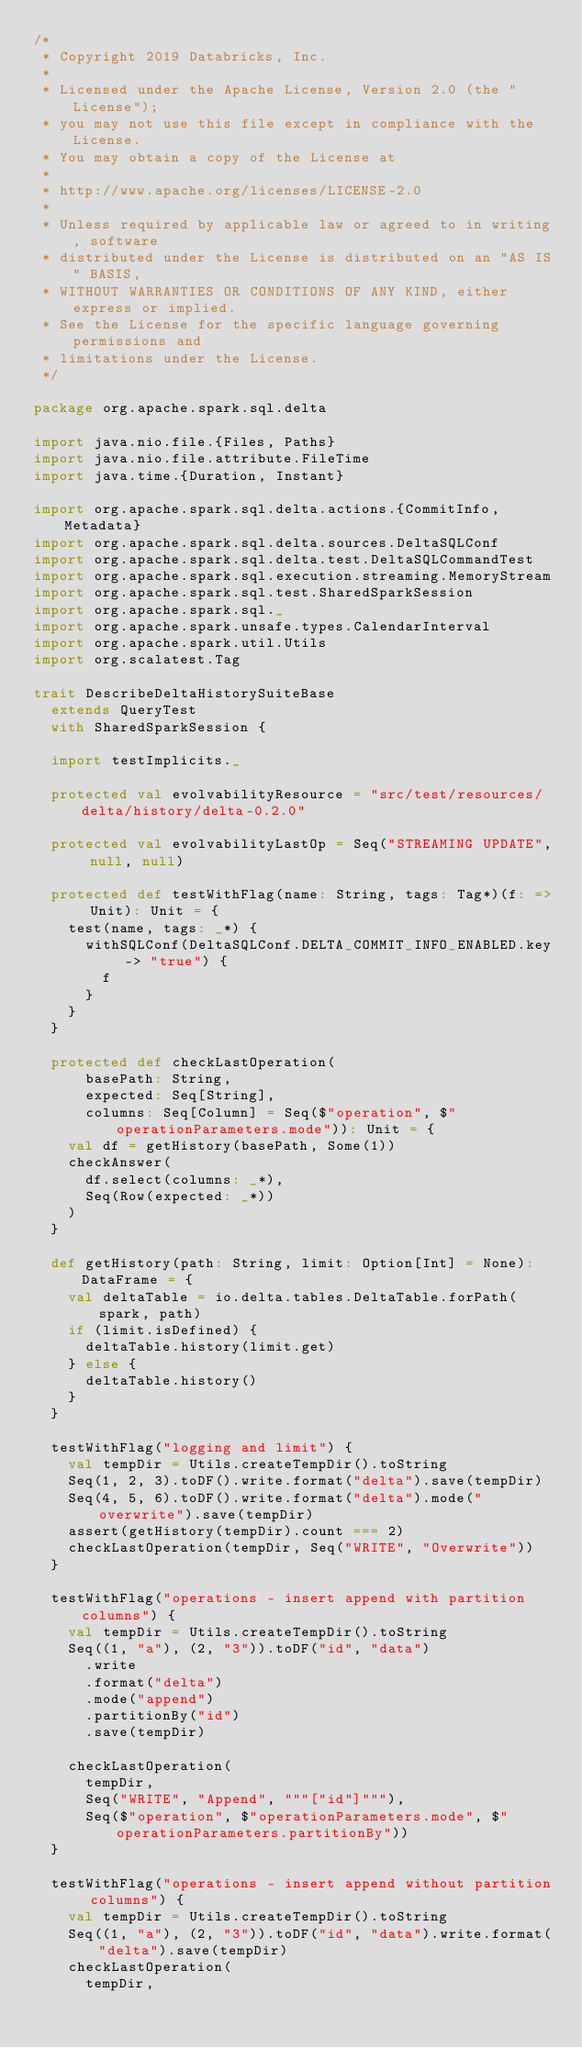<code> <loc_0><loc_0><loc_500><loc_500><_Scala_>/*
 * Copyright 2019 Databricks, Inc.
 *
 * Licensed under the Apache License, Version 2.0 (the "License");
 * you may not use this file except in compliance with the License.
 * You may obtain a copy of the License at
 *
 * http://www.apache.org/licenses/LICENSE-2.0
 *
 * Unless required by applicable law or agreed to in writing, software
 * distributed under the License is distributed on an "AS IS" BASIS,
 * WITHOUT WARRANTIES OR CONDITIONS OF ANY KIND, either express or implied.
 * See the License for the specific language governing permissions and
 * limitations under the License.
 */

package org.apache.spark.sql.delta

import java.nio.file.{Files, Paths}
import java.nio.file.attribute.FileTime
import java.time.{Duration, Instant}

import org.apache.spark.sql.delta.actions.{CommitInfo, Metadata}
import org.apache.spark.sql.delta.sources.DeltaSQLConf
import org.apache.spark.sql.delta.test.DeltaSQLCommandTest
import org.apache.spark.sql.execution.streaming.MemoryStream
import org.apache.spark.sql.test.SharedSparkSession
import org.apache.spark.sql._
import org.apache.spark.unsafe.types.CalendarInterval
import org.apache.spark.util.Utils
import org.scalatest.Tag

trait DescribeDeltaHistorySuiteBase
  extends QueryTest
  with SharedSparkSession {

  import testImplicits._

  protected val evolvabilityResource = "src/test/resources/delta/history/delta-0.2.0"

  protected val evolvabilityLastOp = Seq("STREAMING UPDATE", null, null)

  protected def testWithFlag(name: String, tags: Tag*)(f: => Unit): Unit = {
    test(name, tags: _*) {
      withSQLConf(DeltaSQLConf.DELTA_COMMIT_INFO_ENABLED.key -> "true") {
        f
      }
    }
  }

  protected def checkLastOperation(
      basePath: String,
      expected: Seq[String],
      columns: Seq[Column] = Seq($"operation", $"operationParameters.mode")): Unit = {
    val df = getHistory(basePath, Some(1))
    checkAnswer(
      df.select(columns: _*),
      Seq(Row(expected: _*))
    )
  }

  def getHistory(path: String, limit: Option[Int] = None): DataFrame = {
    val deltaTable = io.delta.tables.DeltaTable.forPath(spark, path)
    if (limit.isDefined) {
      deltaTable.history(limit.get)
    } else {
      deltaTable.history()
    }
  }

  testWithFlag("logging and limit") {
    val tempDir = Utils.createTempDir().toString
    Seq(1, 2, 3).toDF().write.format("delta").save(tempDir)
    Seq(4, 5, 6).toDF().write.format("delta").mode("overwrite").save(tempDir)
    assert(getHistory(tempDir).count === 2)
    checkLastOperation(tempDir, Seq("WRITE", "Overwrite"))
  }

  testWithFlag("operations - insert append with partition columns") {
    val tempDir = Utils.createTempDir().toString
    Seq((1, "a"), (2, "3")).toDF("id", "data")
      .write
      .format("delta")
      .mode("append")
      .partitionBy("id")
      .save(tempDir)

    checkLastOperation(
      tempDir,
      Seq("WRITE", "Append", """["id"]"""),
      Seq($"operation", $"operationParameters.mode", $"operationParameters.partitionBy"))
  }

  testWithFlag("operations - insert append without partition columns") {
    val tempDir = Utils.createTempDir().toString
    Seq((1, "a"), (2, "3")).toDF("id", "data").write.format("delta").save(tempDir)
    checkLastOperation(
      tempDir,</code> 